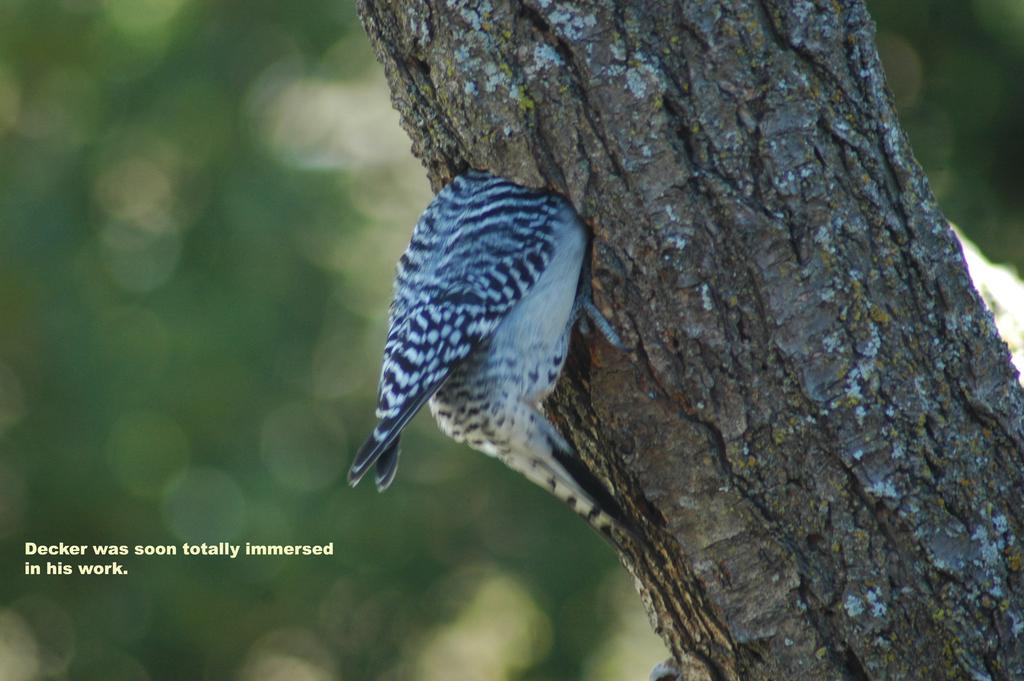What is the main subject of the image? The main subject of the image is a tree trunk. Are there any living creatures visible in the image? Yes, there is a bird in the image. Is there any text present in the image? Yes, there is some text written at the bottom of the image. Where is the throne located in the image? There is no throne present in the image. What type of paste is being used by the servant in the image? There is no servant or paste present in the image. 